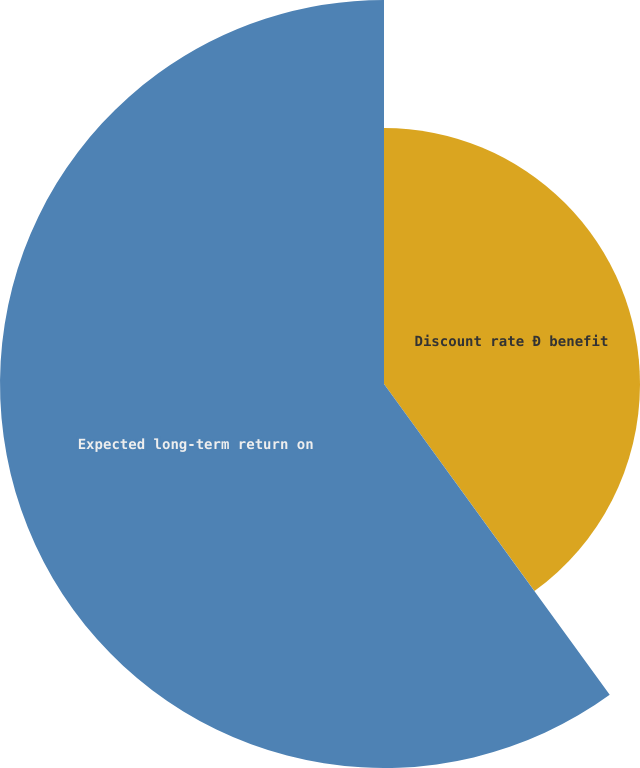Convert chart to OTSL. <chart><loc_0><loc_0><loc_500><loc_500><pie_chart><fcel>Discount rate Ð benefit<fcel>Expected long-term return on<nl><fcel>40.0%<fcel>60.0%<nl></chart> 